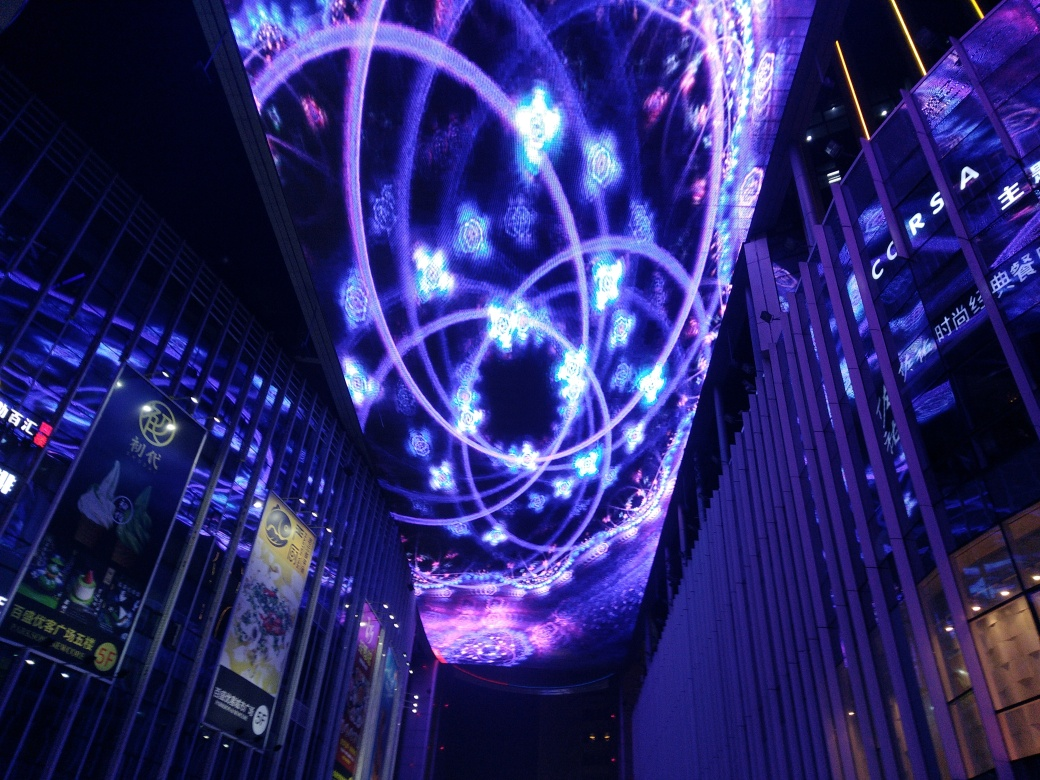Can you guess the possible location where this image was taken? While I cannot provide a specific geographic location, the image seems to be taken in a metropolitan area known for its digital art installations and contemporary architectural style. The inclusion of signage with non-Latin characters suggests it might be in a city where such script is used, pointing to a location in East Asia. 